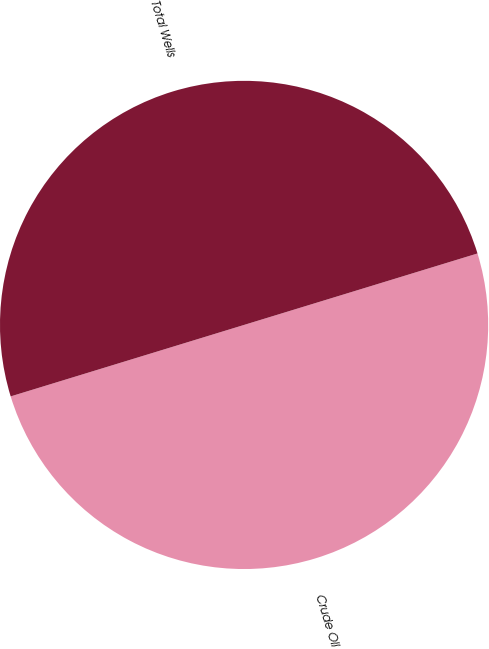Convert chart. <chart><loc_0><loc_0><loc_500><loc_500><pie_chart><fcel>Crude Oil<fcel>Total Wells<nl><fcel>50.0%<fcel>50.0%<nl></chart> 